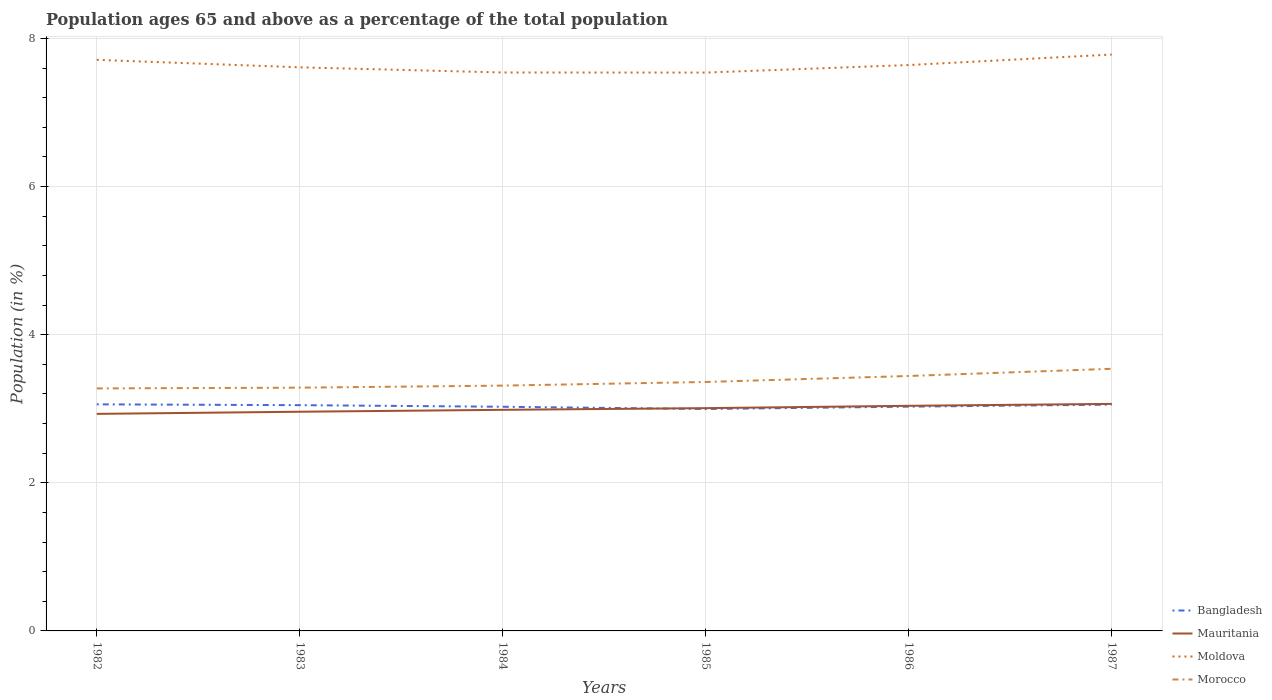How many different coloured lines are there?
Offer a very short reply. 4. Across all years, what is the maximum percentage of the population ages 65 and above in Mauritania?
Keep it short and to the point. 2.93. In which year was the percentage of the population ages 65 and above in Mauritania maximum?
Your response must be concise. 1982. What is the total percentage of the population ages 65 and above in Mauritania in the graph?
Ensure brevity in your answer.  -0.02. What is the difference between the highest and the second highest percentage of the population ages 65 and above in Morocco?
Make the answer very short. 0.26. What is the difference between the highest and the lowest percentage of the population ages 65 and above in Morocco?
Provide a short and direct response. 2. How many lines are there?
Offer a very short reply. 4. How many years are there in the graph?
Provide a succinct answer. 6. Are the values on the major ticks of Y-axis written in scientific E-notation?
Offer a terse response. No. What is the title of the graph?
Ensure brevity in your answer.  Population ages 65 and above as a percentage of the total population. Does "Morocco" appear as one of the legend labels in the graph?
Give a very brief answer. Yes. What is the label or title of the Y-axis?
Give a very brief answer. Population (in %). What is the Population (in %) of Bangladesh in 1982?
Make the answer very short. 3.06. What is the Population (in %) of Mauritania in 1982?
Your answer should be compact. 2.93. What is the Population (in %) of Moldova in 1982?
Your answer should be very brief. 7.71. What is the Population (in %) in Morocco in 1982?
Provide a short and direct response. 3.27. What is the Population (in %) in Bangladesh in 1983?
Offer a terse response. 3.05. What is the Population (in %) in Mauritania in 1983?
Ensure brevity in your answer.  2.96. What is the Population (in %) of Moldova in 1983?
Your answer should be compact. 7.61. What is the Population (in %) of Morocco in 1983?
Offer a terse response. 3.28. What is the Population (in %) in Bangladesh in 1984?
Provide a short and direct response. 3.03. What is the Population (in %) of Mauritania in 1984?
Keep it short and to the point. 2.98. What is the Population (in %) in Moldova in 1984?
Keep it short and to the point. 7.54. What is the Population (in %) of Morocco in 1984?
Your answer should be very brief. 3.31. What is the Population (in %) of Bangladesh in 1985?
Give a very brief answer. 3. What is the Population (in %) of Mauritania in 1985?
Offer a very short reply. 3.01. What is the Population (in %) of Moldova in 1985?
Offer a very short reply. 7.54. What is the Population (in %) in Morocco in 1985?
Your response must be concise. 3.36. What is the Population (in %) in Bangladesh in 1986?
Offer a terse response. 3.03. What is the Population (in %) in Mauritania in 1986?
Keep it short and to the point. 3.04. What is the Population (in %) in Moldova in 1986?
Your answer should be compact. 7.64. What is the Population (in %) in Morocco in 1986?
Ensure brevity in your answer.  3.44. What is the Population (in %) of Bangladesh in 1987?
Provide a succinct answer. 3.06. What is the Population (in %) in Mauritania in 1987?
Offer a very short reply. 3.07. What is the Population (in %) of Moldova in 1987?
Your answer should be compact. 7.78. What is the Population (in %) in Morocco in 1987?
Your answer should be very brief. 3.54. Across all years, what is the maximum Population (in %) of Bangladesh?
Provide a short and direct response. 3.06. Across all years, what is the maximum Population (in %) of Mauritania?
Offer a very short reply. 3.07. Across all years, what is the maximum Population (in %) of Moldova?
Provide a succinct answer. 7.78. Across all years, what is the maximum Population (in %) in Morocco?
Keep it short and to the point. 3.54. Across all years, what is the minimum Population (in %) in Bangladesh?
Provide a short and direct response. 3. Across all years, what is the minimum Population (in %) in Mauritania?
Ensure brevity in your answer.  2.93. Across all years, what is the minimum Population (in %) in Moldova?
Your answer should be compact. 7.54. Across all years, what is the minimum Population (in %) of Morocco?
Give a very brief answer. 3.27. What is the total Population (in %) in Bangladesh in the graph?
Offer a terse response. 18.21. What is the total Population (in %) of Mauritania in the graph?
Your answer should be compact. 17.99. What is the total Population (in %) in Moldova in the graph?
Your answer should be very brief. 45.82. What is the total Population (in %) in Morocco in the graph?
Your answer should be compact. 20.21. What is the difference between the Population (in %) in Bangladesh in 1982 and that in 1983?
Offer a terse response. 0.01. What is the difference between the Population (in %) in Mauritania in 1982 and that in 1983?
Provide a succinct answer. -0.03. What is the difference between the Population (in %) of Moldova in 1982 and that in 1983?
Give a very brief answer. 0.1. What is the difference between the Population (in %) of Morocco in 1982 and that in 1983?
Your answer should be very brief. -0.01. What is the difference between the Population (in %) of Bangladesh in 1982 and that in 1984?
Provide a short and direct response. 0.03. What is the difference between the Population (in %) in Mauritania in 1982 and that in 1984?
Make the answer very short. -0.05. What is the difference between the Population (in %) of Moldova in 1982 and that in 1984?
Offer a very short reply. 0.17. What is the difference between the Population (in %) of Morocco in 1982 and that in 1984?
Keep it short and to the point. -0.04. What is the difference between the Population (in %) in Bangladesh in 1982 and that in 1985?
Provide a short and direct response. 0.06. What is the difference between the Population (in %) in Mauritania in 1982 and that in 1985?
Offer a very short reply. -0.08. What is the difference between the Population (in %) in Moldova in 1982 and that in 1985?
Ensure brevity in your answer.  0.17. What is the difference between the Population (in %) in Morocco in 1982 and that in 1985?
Give a very brief answer. -0.09. What is the difference between the Population (in %) in Bangladesh in 1982 and that in 1986?
Provide a short and direct response. 0.03. What is the difference between the Population (in %) in Mauritania in 1982 and that in 1986?
Provide a succinct answer. -0.11. What is the difference between the Population (in %) of Moldova in 1982 and that in 1986?
Give a very brief answer. 0.07. What is the difference between the Population (in %) of Morocco in 1982 and that in 1986?
Provide a short and direct response. -0.17. What is the difference between the Population (in %) of Bangladesh in 1982 and that in 1987?
Your response must be concise. 0. What is the difference between the Population (in %) in Mauritania in 1982 and that in 1987?
Your answer should be compact. -0.13. What is the difference between the Population (in %) in Moldova in 1982 and that in 1987?
Ensure brevity in your answer.  -0.07. What is the difference between the Population (in %) in Morocco in 1982 and that in 1987?
Give a very brief answer. -0.27. What is the difference between the Population (in %) in Bangladesh in 1983 and that in 1984?
Your answer should be very brief. 0.02. What is the difference between the Population (in %) in Mauritania in 1983 and that in 1984?
Offer a terse response. -0.03. What is the difference between the Population (in %) of Moldova in 1983 and that in 1984?
Ensure brevity in your answer.  0.07. What is the difference between the Population (in %) of Morocco in 1983 and that in 1984?
Your answer should be very brief. -0.03. What is the difference between the Population (in %) in Bangladesh in 1983 and that in 1985?
Offer a very short reply. 0.05. What is the difference between the Population (in %) of Mauritania in 1983 and that in 1985?
Ensure brevity in your answer.  -0.05. What is the difference between the Population (in %) in Moldova in 1983 and that in 1985?
Your response must be concise. 0.07. What is the difference between the Population (in %) of Morocco in 1983 and that in 1985?
Your response must be concise. -0.08. What is the difference between the Population (in %) in Bangladesh in 1983 and that in 1986?
Your answer should be compact. 0.02. What is the difference between the Population (in %) of Mauritania in 1983 and that in 1986?
Give a very brief answer. -0.08. What is the difference between the Population (in %) in Moldova in 1983 and that in 1986?
Give a very brief answer. -0.03. What is the difference between the Population (in %) of Morocco in 1983 and that in 1986?
Your response must be concise. -0.16. What is the difference between the Population (in %) of Bangladesh in 1983 and that in 1987?
Give a very brief answer. -0.01. What is the difference between the Population (in %) in Mauritania in 1983 and that in 1987?
Your response must be concise. -0.11. What is the difference between the Population (in %) in Moldova in 1983 and that in 1987?
Keep it short and to the point. -0.17. What is the difference between the Population (in %) of Morocco in 1983 and that in 1987?
Offer a very short reply. -0.25. What is the difference between the Population (in %) in Bangladesh in 1984 and that in 1985?
Your response must be concise. 0.03. What is the difference between the Population (in %) of Mauritania in 1984 and that in 1985?
Provide a short and direct response. -0.02. What is the difference between the Population (in %) in Moldova in 1984 and that in 1985?
Your response must be concise. 0. What is the difference between the Population (in %) in Morocco in 1984 and that in 1985?
Offer a terse response. -0.05. What is the difference between the Population (in %) in Bangladesh in 1984 and that in 1986?
Provide a short and direct response. -0. What is the difference between the Population (in %) of Mauritania in 1984 and that in 1986?
Ensure brevity in your answer.  -0.05. What is the difference between the Population (in %) of Moldova in 1984 and that in 1986?
Your response must be concise. -0.1. What is the difference between the Population (in %) in Morocco in 1984 and that in 1986?
Make the answer very short. -0.13. What is the difference between the Population (in %) of Bangladesh in 1984 and that in 1987?
Offer a terse response. -0.03. What is the difference between the Population (in %) in Mauritania in 1984 and that in 1987?
Your response must be concise. -0.08. What is the difference between the Population (in %) in Moldova in 1984 and that in 1987?
Your answer should be very brief. -0.24. What is the difference between the Population (in %) of Morocco in 1984 and that in 1987?
Keep it short and to the point. -0.23. What is the difference between the Population (in %) in Bangladesh in 1985 and that in 1986?
Give a very brief answer. -0.03. What is the difference between the Population (in %) of Mauritania in 1985 and that in 1986?
Your response must be concise. -0.03. What is the difference between the Population (in %) in Moldova in 1985 and that in 1986?
Your answer should be very brief. -0.1. What is the difference between the Population (in %) of Morocco in 1985 and that in 1986?
Keep it short and to the point. -0.08. What is the difference between the Population (in %) of Bangladesh in 1985 and that in 1987?
Provide a succinct answer. -0.06. What is the difference between the Population (in %) in Mauritania in 1985 and that in 1987?
Offer a very short reply. -0.06. What is the difference between the Population (in %) of Moldova in 1985 and that in 1987?
Keep it short and to the point. -0.24. What is the difference between the Population (in %) of Morocco in 1985 and that in 1987?
Make the answer very short. -0.18. What is the difference between the Population (in %) of Bangladesh in 1986 and that in 1987?
Ensure brevity in your answer.  -0.03. What is the difference between the Population (in %) of Mauritania in 1986 and that in 1987?
Offer a very short reply. -0.03. What is the difference between the Population (in %) in Moldova in 1986 and that in 1987?
Ensure brevity in your answer.  -0.14. What is the difference between the Population (in %) of Morocco in 1986 and that in 1987?
Keep it short and to the point. -0.1. What is the difference between the Population (in %) of Bangladesh in 1982 and the Population (in %) of Mauritania in 1983?
Make the answer very short. 0.1. What is the difference between the Population (in %) of Bangladesh in 1982 and the Population (in %) of Moldova in 1983?
Offer a very short reply. -4.55. What is the difference between the Population (in %) in Bangladesh in 1982 and the Population (in %) in Morocco in 1983?
Your response must be concise. -0.23. What is the difference between the Population (in %) in Mauritania in 1982 and the Population (in %) in Moldova in 1983?
Ensure brevity in your answer.  -4.68. What is the difference between the Population (in %) in Mauritania in 1982 and the Population (in %) in Morocco in 1983?
Your answer should be very brief. -0.35. What is the difference between the Population (in %) of Moldova in 1982 and the Population (in %) of Morocco in 1983?
Your response must be concise. 4.43. What is the difference between the Population (in %) in Bangladesh in 1982 and the Population (in %) in Mauritania in 1984?
Give a very brief answer. 0.07. What is the difference between the Population (in %) of Bangladesh in 1982 and the Population (in %) of Moldova in 1984?
Your answer should be very brief. -4.48. What is the difference between the Population (in %) of Bangladesh in 1982 and the Population (in %) of Morocco in 1984?
Offer a terse response. -0.25. What is the difference between the Population (in %) of Mauritania in 1982 and the Population (in %) of Moldova in 1984?
Offer a terse response. -4.61. What is the difference between the Population (in %) of Mauritania in 1982 and the Population (in %) of Morocco in 1984?
Your answer should be compact. -0.38. What is the difference between the Population (in %) in Moldova in 1982 and the Population (in %) in Morocco in 1984?
Your answer should be very brief. 4.4. What is the difference between the Population (in %) in Bangladesh in 1982 and the Population (in %) in Mauritania in 1985?
Keep it short and to the point. 0.05. What is the difference between the Population (in %) of Bangladesh in 1982 and the Population (in %) of Moldova in 1985?
Your response must be concise. -4.48. What is the difference between the Population (in %) in Bangladesh in 1982 and the Population (in %) in Morocco in 1985?
Keep it short and to the point. -0.3. What is the difference between the Population (in %) in Mauritania in 1982 and the Population (in %) in Moldova in 1985?
Ensure brevity in your answer.  -4.61. What is the difference between the Population (in %) in Mauritania in 1982 and the Population (in %) in Morocco in 1985?
Offer a very short reply. -0.43. What is the difference between the Population (in %) of Moldova in 1982 and the Population (in %) of Morocco in 1985?
Make the answer very short. 4.35. What is the difference between the Population (in %) of Bangladesh in 1982 and the Population (in %) of Mauritania in 1986?
Offer a terse response. 0.02. What is the difference between the Population (in %) in Bangladesh in 1982 and the Population (in %) in Moldova in 1986?
Your answer should be compact. -4.58. What is the difference between the Population (in %) of Bangladesh in 1982 and the Population (in %) of Morocco in 1986?
Provide a succinct answer. -0.38. What is the difference between the Population (in %) of Mauritania in 1982 and the Population (in %) of Moldova in 1986?
Your response must be concise. -4.71. What is the difference between the Population (in %) of Mauritania in 1982 and the Population (in %) of Morocco in 1986?
Ensure brevity in your answer.  -0.51. What is the difference between the Population (in %) of Moldova in 1982 and the Population (in %) of Morocco in 1986?
Your answer should be compact. 4.27. What is the difference between the Population (in %) in Bangladesh in 1982 and the Population (in %) in Mauritania in 1987?
Provide a short and direct response. -0.01. What is the difference between the Population (in %) of Bangladesh in 1982 and the Population (in %) of Moldova in 1987?
Your answer should be compact. -4.72. What is the difference between the Population (in %) in Bangladesh in 1982 and the Population (in %) in Morocco in 1987?
Keep it short and to the point. -0.48. What is the difference between the Population (in %) in Mauritania in 1982 and the Population (in %) in Moldova in 1987?
Your answer should be very brief. -4.85. What is the difference between the Population (in %) in Mauritania in 1982 and the Population (in %) in Morocco in 1987?
Offer a terse response. -0.61. What is the difference between the Population (in %) of Moldova in 1982 and the Population (in %) of Morocco in 1987?
Keep it short and to the point. 4.17. What is the difference between the Population (in %) of Bangladesh in 1983 and the Population (in %) of Mauritania in 1984?
Offer a very short reply. 0.06. What is the difference between the Population (in %) of Bangladesh in 1983 and the Population (in %) of Moldova in 1984?
Offer a very short reply. -4.49. What is the difference between the Population (in %) of Bangladesh in 1983 and the Population (in %) of Morocco in 1984?
Your answer should be very brief. -0.26. What is the difference between the Population (in %) of Mauritania in 1983 and the Population (in %) of Moldova in 1984?
Make the answer very short. -4.58. What is the difference between the Population (in %) of Mauritania in 1983 and the Population (in %) of Morocco in 1984?
Ensure brevity in your answer.  -0.35. What is the difference between the Population (in %) of Moldova in 1983 and the Population (in %) of Morocco in 1984?
Make the answer very short. 4.3. What is the difference between the Population (in %) in Bangladesh in 1983 and the Population (in %) in Mauritania in 1985?
Your response must be concise. 0.04. What is the difference between the Population (in %) in Bangladesh in 1983 and the Population (in %) in Moldova in 1985?
Make the answer very short. -4.49. What is the difference between the Population (in %) of Bangladesh in 1983 and the Population (in %) of Morocco in 1985?
Offer a very short reply. -0.31. What is the difference between the Population (in %) in Mauritania in 1983 and the Population (in %) in Moldova in 1985?
Your answer should be compact. -4.58. What is the difference between the Population (in %) in Mauritania in 1983 and the Population (in %) in Morocco in 1985?
Keep it short and to the point. -0.4. What is the difference between the Population (in %) in Moldova in 1983 and the Population (in %) in Morocco in 1985?
Provide a succinct answer. 4.25. What is the difference between the Population (in %) in Bangladesh in 1983 and the Population (in %) in Mauritania in 1986?
Offer a very short reply. 0.01. What is the difference between the Population (in %) in Bangladesh in 1983 and the Population (in %) in Moldova in 1986?
Offer a very short reply. -4.59. What is the difference between the Population (in %) of Bangladesh in 1983 and the Population (in %) of Morocco in 1986?
Provide a short and direct response. -0.39. What is the difference between the Population (in %) of Mauritania in 1983 and the Population (in %) of Moldova in 1986?
Offer a terse response. -4.68. What is the difference between the Population (in %) of Mauritania in 1983 and the Population (in %) of Morocco in 1986?
Make the answer very short. -0.48. What is the difference between the Population (in %) in Moldova in 1983 and the Population (in %) in Morocco in 1986?
Provide a succinct answer. 4.17. What is the difference between the Population (in %) of Bangladesh in 1983 and the Population (in %) of Mauritania in 1987?
Your answer should be compact. -0.02. What is the difference between the Population (in %) in Bangladesh in 1983 and the Population (in %) in Moldova in 1987?
Ensure brevity in your answer.  -4.73. What is the difference between the Population (in %) in Bangladesh in 1983 and the Population (in %) in Morocco in 1987?
Your answer should be very brief. -0.49. What is the difference between the Population (in %) of Mauritania in 1983 and the Population (in %) of Moldova in 1987?
Give a very brief answer. -4.82. What is the difference between the Population (in %) in Mauritania in 1983 and the Population (in %) in Morocco in 1987?
Give a very brief answer. -0.58. What is the difference between the Population (in %) of Moldova in 1983 and the Population (in %) of Morocco in 1987?
Make the answer very short. 4.07. What is the difference between the Population (in %) in Bangladesh in 1984 and the Population (in %) in Mauritania in 1985?
Offer a terse response. 0.02. What is the difference between the Population (in %) of Bangladesh in 1984 and the Population (in %) of Moldova in 1985?
Your answer should be very brief. -4.51. What is the difference between the Population (in %) of Bangladesh in 1984 and the Population (in %) of Morocco in 1985?
Give a very brief answer. -0.33. What is the difference between the Population (in %) of Mauritania in 1984 and the Population (in %) of Moldova in 1985?
Your answer should be very brief. -4.55. What is the difference between the Population (in %) in Mauritania in 1984 and the Population (in %) in Morocco in 1985?
Keep it short and to the point. -0.38. What is the difference between the Population (in %) in Moldova in 1984 and the Population (in %) in Morocco in 1985?
Provide a short and direct response. 4.18. What is the difference between the Population (in %) in Bangladesh in 1984 and the Population (in %) in Mauritania in 1986?
Ensure brevity in your answer.  -0.01. What is the difference between the Population (in %) of Bangladesh in 1984 and the Population (in %) of Moldova in 1986?
Keep it short and to the point. -4.61. What is the difference between the Population (in %) in Bangladesh in 1984 and the Population (in %) in Morocco in 1986?
Your answer should be compact. -0.42. What is the difference between the Population (in %) in Mauritania in 1984 and the Population (in %) in Moldova in 1986?
Your answer should be compact. -4.66. What is the difference between the Population (in %) of Mauritania in 1984 and the Population (in %) of Morocco in 1986?
Offer a very short reply. -0.46. What is the difference between the Population (in %) in Moldova in 1984 and the Population (in %) in Morocco in 1986?
Make the answer very short. 4.1. What is the difference between the Population (in %) of Bangladesh in 1984 and the Population (in %) of Mauritania in 1987?
Make the answer very short. -0.04. What is the difference between the Population (in %) in Bangladesh in 1984 and the Population (in %) in Moldova in 1987?
Provide a short and direct response. -4.76. What is the difference between the Population (in %) in Bangladesh in 1984 and the Population (in %) in Morocco in 1987?
Your response must be concise. -0.51. What is the difference between the Population (in %) in Mauritania in 1984 and the Population (in %) in Moldova in 1987?
Provide a short and direct response. -4.8. What is the difference between the Population (in %) in Mauritania in 1984 and the Population (in %) in Morocco in 1987?
Make the answer very short. -0.55. What is the difference between the Population (in %) of Moldova in 1984 and the Population (in %) of Morocco in 1987?
Provide a short and direct response. 4. What is the difference between the Population (in %) of Bangladesh in 1985 and the Population (in %) of Mauritania in 1986?
Make the answer very short. -0.04. What is the difference between the Population (in %) in Bangladesh in 1985 and the Population (in %) in Moldova in 1986?
Provide a short and direct response. -4.64. What is the difference between the Population (in %) of Bangladesh in 1985 and the Population (in %) of Morocco in 1986?
Offer a terse response. -0.45. What is the difference between the Population (in %) in Mauritania in 1985 and the Population (in %) in Moldova in 1986?
Provide a succinct answer. -4.63. What is the difference between the Population (in %) in Mauritania in 1985 and the Population (in %) in Morocco in 1986?
Keep it short and to the point. -0.43. What is the difference between the Population (in %) of Moldova in 1985 and the Population (in %) of Morocco in 1986?
Ensure brevity in your answer.  4.1. What is the difference between the Population (in %) in Bangladesh in 1985 and the Population (in %) in Mauritania in 1987?
Your answer should be very brief. -0.07. What is the difference between the Population (in %) of Bangladesh in 1985 and the Population (in %) of Moldova in 1987?
Offer a very short reply. -4.79. What is the difference between the Population (in %) of Bangladesh in 1985 and the Population (in %) of Morocco in 1987?
Offer a very short reply. -0.54. What is the difference between the Population (in %) of Mauritania in 1985 and the Population (in %) of Moldova in 1987?
Provide a succinct answer. -4.77. What is the difference between the Population (in %) of Mauritania in 1985 and the Population (in %) of Morocco in 1987?
Provide a short and direct response. -0.53. What is the difference between the Population (in %) of Moldova in 1985 and the Population (in %) of Morocco in 1987?
Your answer should be compact. 4. What is the difference between the Population (in %) of Bangladesh in 1986 and the Population (in %) of Mauritania in 1987?
Your response must be concise. -0.04. What is the difference between the Population (in %) in Bangladesh in 1986 and the Population (in %) in Moldova in 1987?
Offer a very short reply. -4.75. What is the difference between the Population (in %) in Bangladesh in 1986 and the Population (in %) in Morocco in 1987?
Your answer should be very brief. -0.51. What is the difference between the Population (in %) of Mauritania in 1986 and the Population (in %) of Moldova in 1987?
Offer a very short reply. -4.74. What is the difference between the Population (in %) in Mauritania in 1986 and the Population (in %) in Morocco in 1987?
Provide a short and direct response. -0.5. What is the difference between the Population (in %) in Moldova in 1986 and the Population (in %) in Morocco in 1987?
Your answer should be compact. 4.1. What is the average Population (in %) of Bangladesh per year?
Provide a short and direct response. 3.04. What is the average Population (in %) of Mauritania per year?
Offer a very short reply. 3. What is the average Population (in %) in Moldova per year?
Your answer should be very brief. 7.64. What is the average Population (in %) of Morocco per year?
Provide a succinct answer. 3.37. In the year 1982, what is the difference between the Population (in %) in Bangladesh and Population (in %) in Mauritania?
Ensure brevity in your answer.  0.13. In the year 1982, what is the difference between the Population (in %) of Bangladesh and Population (in %) of Moldova?
Make the answer very short. -4.65. In the year 1982, what is the difference between the Population (in %) in Bangladesh and Population (in %) in Morocco?
Provide a succinct answer. -0.21. In the year 1982, what is the difference between the Population (in %) of Mauritania and Population (in %) of Moldova?
Provide a short and direct response. -4.78. In the year 1982, what is the difference between the Population (in %) of Mauritania and Population (in %) of Morocco?
Offer a very short reply. -0.34. In the year 1982, what is the difference between the Population (in %) in Moldova and Population (in %) in Morocco?
Offer a terse response. 4.44. In the year 1983, what is the difference between the Population (in %) of Bangladesh and Population (in %) of Mauritania?
Give a very brief answer. 0.09. In the year 1983, what is the difference between the Population (in %) in Bangladesh and Population (in %) in Moldova?
Your response must be concise. -4.56. In the year 1983, what is the difference between the Population (in %) of Bangladesh and Population (in %) of Morocco?
Provide a short and direct response. -0.24. In the year 1983, what is the difference between the Population (in %) in Mauritania and Population (in %) in Moldova?
Your answer should be very brief. -4.65. In the year 1983, what is the difference between the Population (in %) in Mauritania and Population (in %) in Morocco?
Keep it short and to the point. -0.33. In the year 1983, what is the difference between the Population (in %) in Moldova and Population (in %) in Morocco?
Your answer should be very brief. 4.32. In the year 1984, what is the difference between the Population (in %) of Bangladesh and Population (in %) of Mauritania?
Give a very brief answer. 0.04. In the year 1984, what is the difference between the Population (in %) in Bangladesh and Population (in %) in Moldova?
Provide a succinct answer. -4.51. In the year 1984, what is the difference between the Population (in %) in Bangladesh and Population (in %) in Morocco?
Your response must be concise. -0.29. In the year 1984, what is the difference between the Population (in %) of Mauritania and Population (in %) of Moldova?
Provide a succinct answer. -4.55. In the year 1984, what is the difference between the Population (in %) of Mauritania and Population (in %) of Morocco?
Offer a terse response. -0.33. In the year 1984, what is the difference between the Population (in %) of Moldova and Population (in %) of Morocco?
Offer a terse response. 4.23. In the year 1985, what is the difference between the Population (in %) in Bangladesh and Population (in %) in Mauritania?
Give a very brief answer. -0.01. In the year 1985, what is the difference between the Population (in %) of Bangladesh and Population (in %) of Moldova?
Your answer should be compact. -4.54. In the year 1985, what is the difference between the Population (in %) in Bangladesh and Population (in %) in Morocco?
Give a very brief answer. -0.37. In the year 1985, what is the difference between the Population (in %) in Mauritania and Population (in %) in Moldova?
Offer a terse response. -4.53. In the year 1985, what is the difference between the Population (in %) of Mauritania and Population (in %) of Morocco?
Your answer should be compact. -0.35. In the year 1985, what is the difference between the Population (in %) in Moldova and Population (in %) in Morocco?
Your response must be concise. 4.18. In the year 1986, what is the difference between the Population (in %) in Bangladesh and Population (in %) in Mauritania?
Your response must be concise. -0.01. In the year 1986, what is the difference between the Population (in %) in Bangladesh and Population (in %) in Moldova?
Your response must be concise. -4.61. In the year 1986, what is the difference between the Population (in %) in Bangladesh and Population (in %) in Morocco?
Your answer should be compact. -0.41. In the year 1986, what is the difference between the Population (in %) in Mauritania and Population (in %) in Moldova?
Keep it short and to the point. -4.6. In the year 1986, what is the difference between the Population (in %) of Mauritania and Population (in %) of Morocco?
Give a very brief answer. -0.4. In the year 1986, what is the difference between the Population (in %) of Moldova and Population (in %) of Morocco?
Provide a succinct answer. 4.2. In the year 1987, what is the difference between the Population (in %) of Bangladesh and Population (in %) of Mauritania?
Provide a succinct answer. -0.01. In the year 1987, what is the difference between the Population (in %) of Bangladesh and Population (in %) of Moldova?
Keep it short and to the point. -4.73. In the year 1987, what is the difference between the Population (in %) of Bangladesh and Population (in %) of Morocco?
Provide a short and direct response. -0.48. In the year 1987, what is the difference between the Population (in %) of Mauritania and Population (in %) of Moldova?
Your answer should be compact. -4.72. In the year 1987, what is the difference between the Population (in %) in Mauritania and Population (in %) in Morocco?
Your answer should be very brief. -0.47. In the year 1987, what is the difference between the Population (in %) of Moldova and Population (in %) of Morocco?
Your response must be concise. 4.24. What is the ratio of the Population (in %) in Bangladesh in 1982 to that in 1983?
Offer a very short reply. 1. What is the ratio of the Population (in %) of Mauritania in 1982 to that in 1983?
Your answer should be very brief. 0.99. What is the ratio of the Population (in %) of Moldova in 1982 to that in 1983?
Make the answer very short. 1.01. What is the ratio of the Population (in %) in Bangladesh in 1982 to that in 1984?
Provide a short and direct response. 1.01. What is the ratio of the Population (in %) in Mauritania in 1982 to that in 1984?
Your answer should be compact. 0.98. What is the ratio of the Population (in %) in Moldova in 1982 to that in 1984?
Make the answer very short. 1.02. What is the ratio of the Population (in %) of Bangladesh in 1982 to that in 1985?
Offer a terse response. 1.02. What is the ratio of the Population (in %) in Mauritania in 1982 to that in 1985?
Your answer should be compact. 0.97. What is the ratio of the Population (in %) of Moldova in 1982 to that in 1985?
Offer a very short reply. 1.02. What is the ratio of the Population (in %) in Morocco in 1982 to that in 1985?
Offer a terse response. 0.97. What is the ratio of the Population (in %) in Bangladesh in 1982 to that in 1986?
Your response must be concise. 1.01. What is the ratio of the Population (in %) in Mauritania in 1982 to that in 1986?
Offer a very short reply. 0.96. What is the ratio of the Population (in %) of Moldova in 1982 to that in 1986?
Keep it short and to the point. 1.01. What is the ratio of the Population (in %) of Morocco in 1982 to that in 1986?
Keep it short and to the point. 0.95. What is the ratio of the Population (in %) of Bangladesh in 1982 to that in 1987?
Offer a very short reply. 1. What is the ratio of the Population (in %) in Mauritania in 1982 to that in 1987?
Give a very brief answer. 0.96. What is the ratio of the Population (in %) in Morocco in 1982 to that in 1987?
Your answer should be very brief. 0.93. What is the ratio of the Population (in %) of Bangladesh in 1983 to that in 1984?
Your answer should be very brief. 1.01. What is the ratio of the Population (in %) of Moldova in 1983 to that in 1984?
Make the answer very short. 1.01. What is the ratio of the Population (in %) of Bangladesh in 1983 to that in 1985?
Provide a succinct answer. 1.02. What is the ratio of the Population (in %) of Mauritania in 1983 to that in 1985?
Your answer should be compact. 0.98. What is the ratio of the Population (in %) of Moldova in 1983 to that in 1985?
Give a very brief answer. 1.01. What is the ratio of the Population (in %) of Morocco in 1983 to that in 1985?
Your answer should be very brief. 0.98. What is the ratio of the Population (in %) of Bangladesh in 1983 to that in 1986?
Your response must be concise. 1.01. What is the ratio of the Population (in %) in Mauritania in 1983 to that in 1986?
Provide a succinct answer. 0.97. What is the ratio of the Population (in %) of Moldova in 1983 to that in 1986?
Give a very brief answer. 1. What is the ratio of the Population (in %) in Morocco in 1983 to that in 1986?
Provide a short and direct response. 0.95. What is the ratio of the Population (in %) in Bangladesh in 1983 to that in 1987?
Provide a succinct answer. 1. What is the ratio of the Population (in %) of Mauritania in 1983 to that in 1987?
Make the answer very short. 0.97. What is the ratio of the Population (in %) in Moldova in 1983 to that in 1987?
Make the answer very short. 0.98. What is the ratio of the Population (in %) of Morocco in 1983 to that in 1987?
Offer a very short reply. 0.93. What is the ratio of the Population (in %) in Bangladesh in 1984 to that in 1985?
Offer a terse response. 1.01. What is the ratio of the Population (in %) of Morocco in 1984 to that in 1985?
Provide a short and direct response. 0.99. What is the ratio of the Population (in %) of Mauritania in 1984 to that in 1986?
Your response must be concise. 0.98. What is the ratio of the Population (in %) of Moldova in 1984 to that in 1986?
Your response must be concise. 0.99. What is the ratio of the Population (in %) in Morocco in 1984 to that in 1986?
Ensure brevity in your answer.  0.96. What is the ratio of the Population (in %) in Mauritania in 1984 to that in 1987?
Keep it short and to the point. 0.97. What is the ratio of the Population (in %) of Moldova in 1984 to that in 1987?
Offer a terse response. 0.97. What is the ratio of the Population (in %) of Morocco in 1984 to that in 1987?
Provide a short and direct response. 0.94. What is the ratio of the Population (in %) of Bangladesh in 1985 to that in 1986?
Provide a succinct answer. 0.99. What is the ratio of the Population (in %) in Mauritania in 1985 to that in 1986?
Your answer should be very brief. 0.99. What is the ratio of the Population (in %) in Moldova in 1985 to that in 1986?
Provide a succinct answer. 0.99. What is the ratio of the Population (in %) of Morocco in 1985 to that in 1986?
Provide a short and direct response. 0.98. What is the ratio of the Population (in %) in Bangladesh in 1985 to that in 1987?
Keep it short and to the point. 0.98. What is the ratio of the Population (in %) in Mauritania in 1985 to that in 1987?
Make the answer very short. 0.98. What is the ratio of the Population (in %) of Moldova in 1985 to that in 1987?
Keep it short and to the point. 0.97. What is the ratio of the Population (in %) of Morocco in 1985 to that in 1987?
Ensure brevity in your answer.  0.95. What is the ratio of the Population (in %) of Moldova in 1986 to that in 1987?
Offer a terse response. 0.98. What is the ratio of the Population (in %) of Morocco in 1986 to that in 1987?
Ensure brevity in your answer.  0.97. What is the difference between the highest and the second highest Population (in %) of Bangladesh?
Your answer should be compact. 0. What is the difference between the highest and the second highest Population (in %) of Mauritania?
Your answer should be very brief. 0.03. What is the difference between the highest and the second highest Population (in %) of Moldova?
Your response must be concise. 0.07. What is the difference between the highest and the second highest Population (in %) of Morocco?
Keep it short and to the point. 0.1. What is the difference between the highest and the lowest Population (in %) in Bangladesh?
Make the answer very short. 0.06. What is the difference between the highest and the lowest Population (in %) of Mauritania?
Make the answer very short. 0.13. What is the difference between the highest and the lowest Population (in %) of Moldova?
Keep it short and to the point. 0.24. What is the difference between the highest and the lowest Population (in %) in Morocco?
Give a very brief answer. 0.27. 